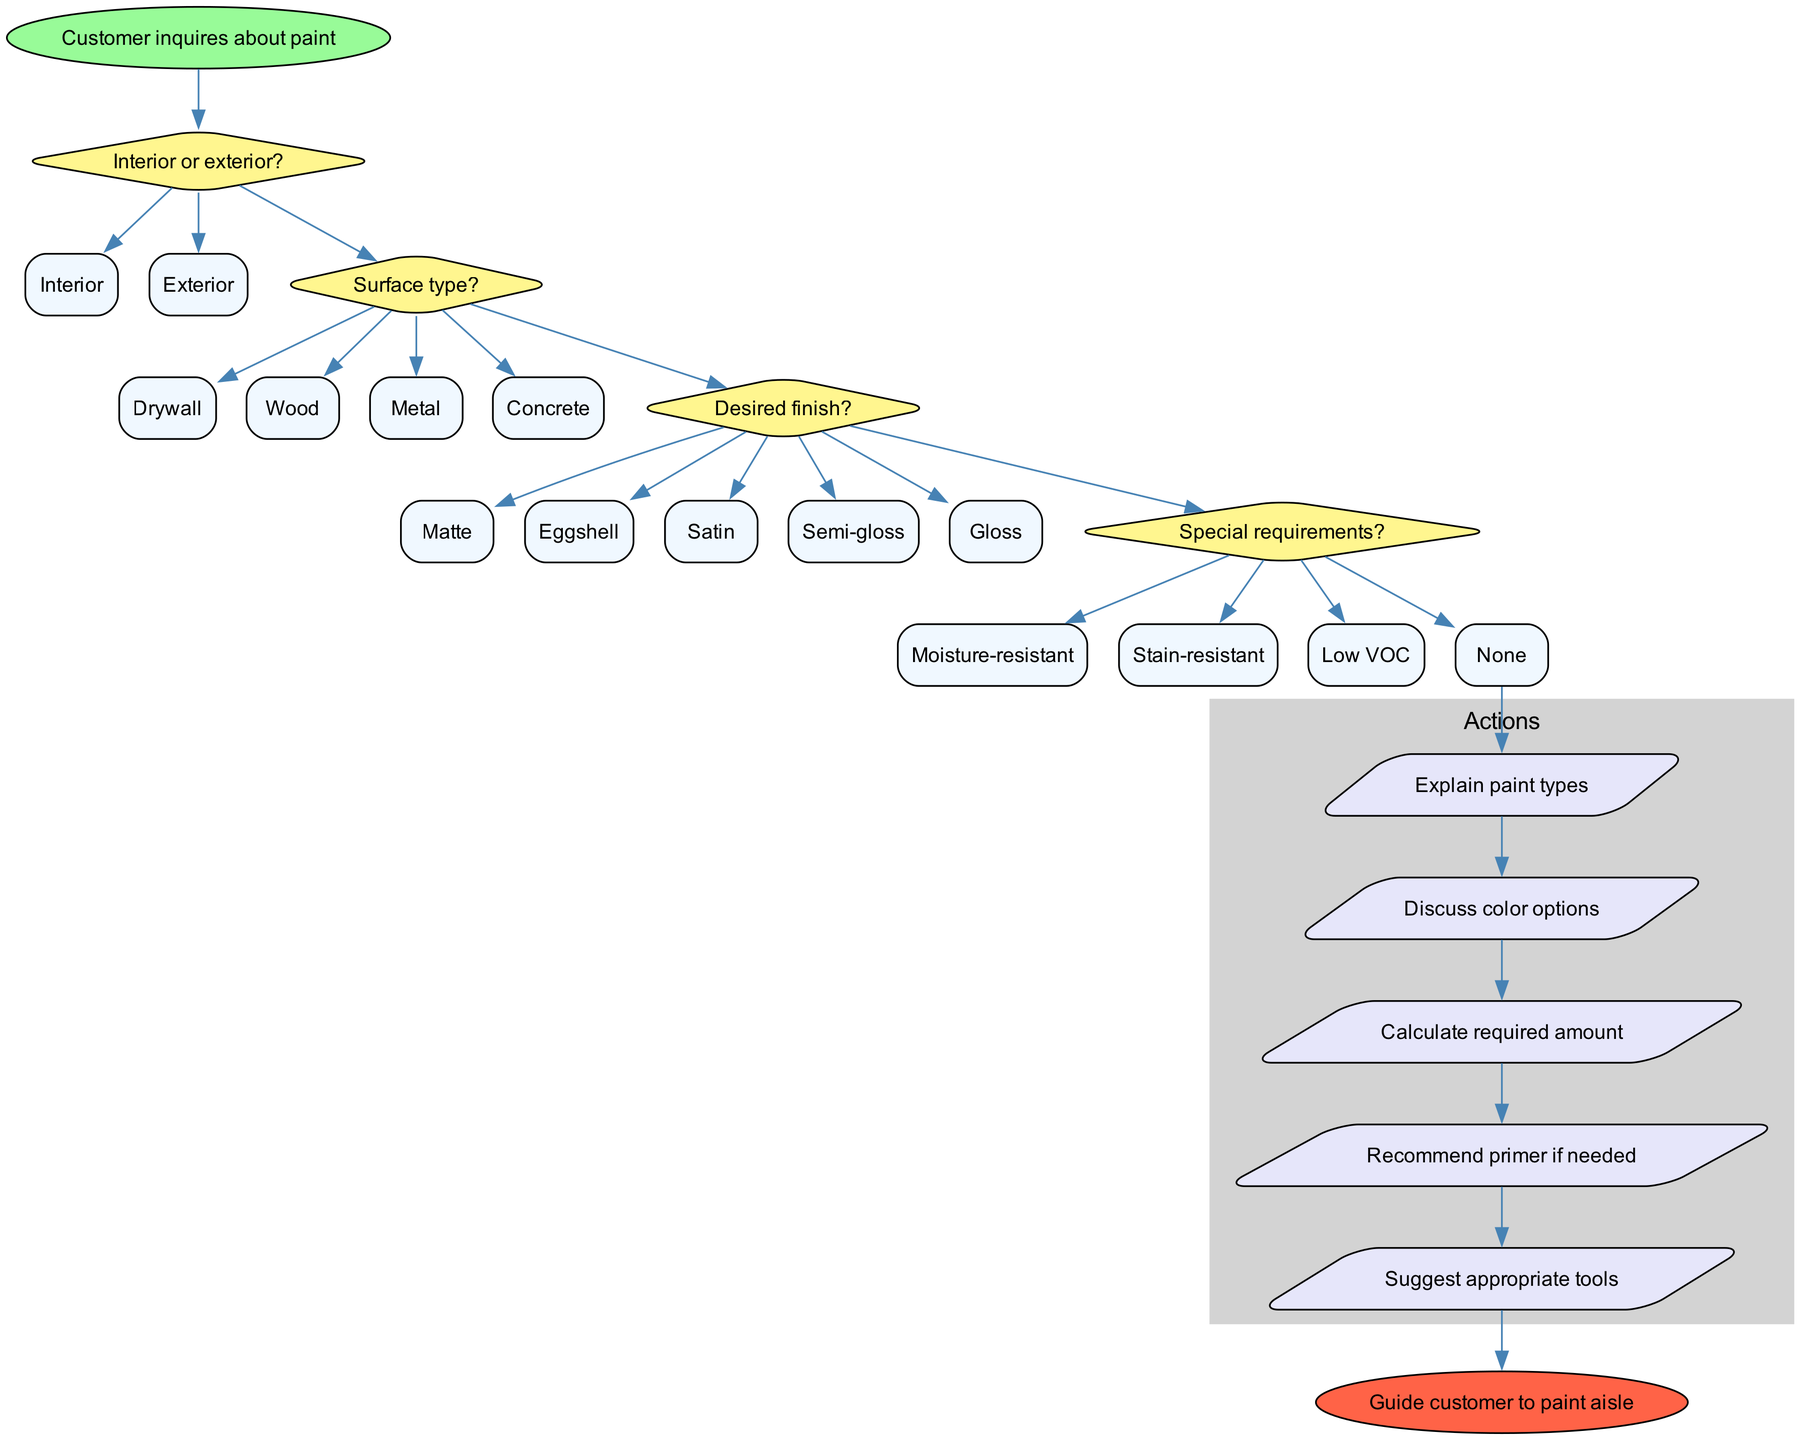What is the starting point of the process? The starting point of the diagram is labeled "Customer inquires about paint." This is the initial node that indicates where the process begins.
Answer: Customer inquires about paint How many decisions are made in the process? There are four decision nodes in the diagram, which include choices about whether the paint is for interior or exterior, the surface type, the desired finish, and any special requirements.
Answer: 4 What are the options for the first decision? The first decision asks, "Interior or exterior?" The options provided for this decision are "Interior" and "Exterior."
Answer: Interior, Exterior Which action follows the last decision? After the last decision about special requirements, the next action is to "Explain paint types." This indicates what is done after all decisions are made.
Answer: Explain paint types What is the color of the end node? The end node, which signifies the conclusion of the process, is colored "#FF6347," which is a shade of red. This color indicates a point of completion in the flow.
Answer: #FF6347 What happens if the customer selects “Concrete” as the surface type? If the customer selects "Concrete," it leads to the next decision regarding the desired finish, passing through the surface type decision of "Concrete." Thus, it doesn't conclude immediately; instead, it continues to the next node in the process.
Answer: Proceeds to desired finish How are the actions grouped in the diagram? The actions in the diagram are grouped together in a subgraph labeled "Actions." This grouping visually distinguishes them from the decision nodes, showing that they occur after the decision-making process is complete.
Answer: Actions What is the final outcome of the process? The final outcome of the process is achieved when the customer is guided to the paint aisle, which is the end node of the diagram. This marks the point where the process concludes and the customer receives assistance.
Answer: Guide customer to paint aisle What type of finish options are available according to the diagram? The finish options provided in the decision node are "Matte," "Eggshell," "Satin," "Semi-gloss," and "Gloss." This gives a clear view of the choices available regarding the paint finish.
Answer: Matte, Eggshell, Satin, Semi-gloss, Gloss 